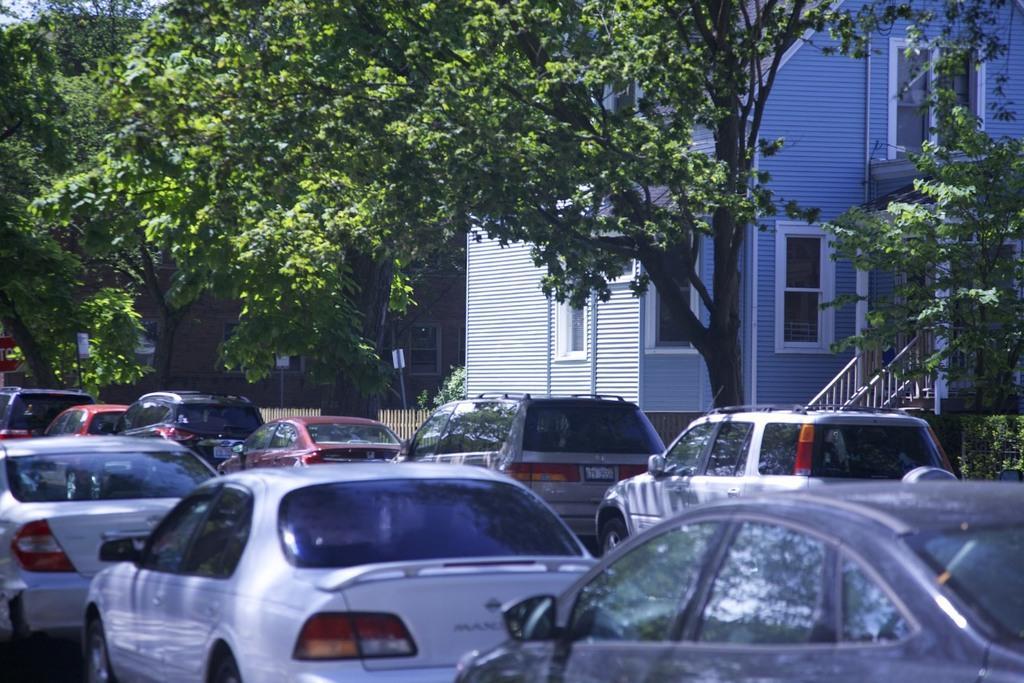How would you summarize this image in a sentence or two? In this image there are many cars on the road. Beside the cars there are trees, plants and hedges. Behind them there are buildings. 